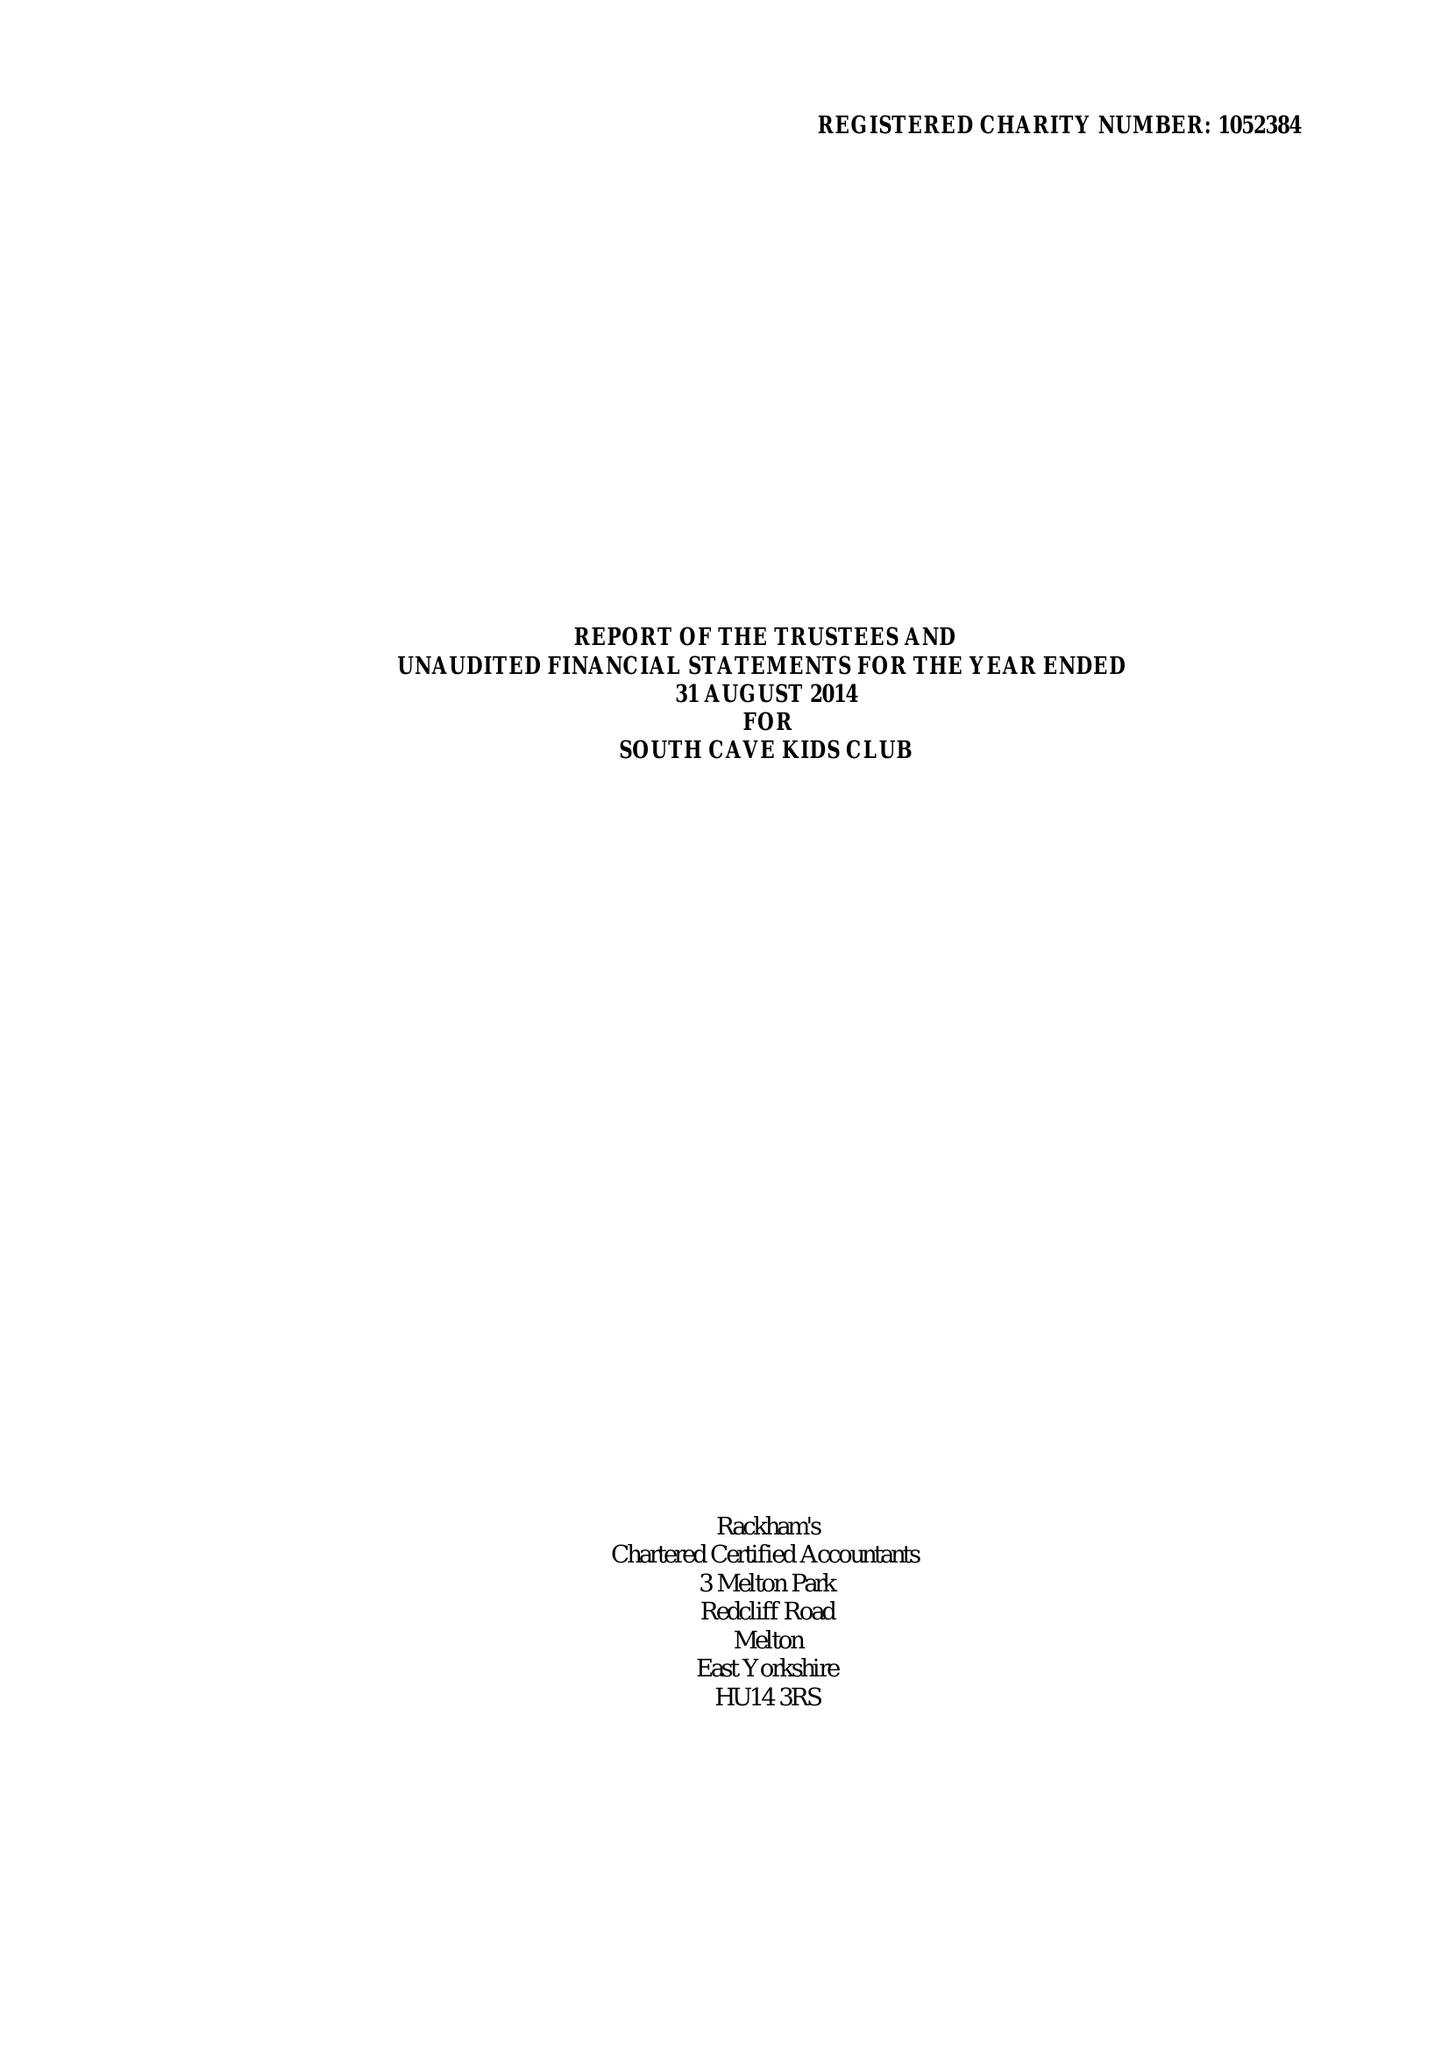What is the value for the report_date?
Answer the question using a single word or phrase. 2014-08-31 